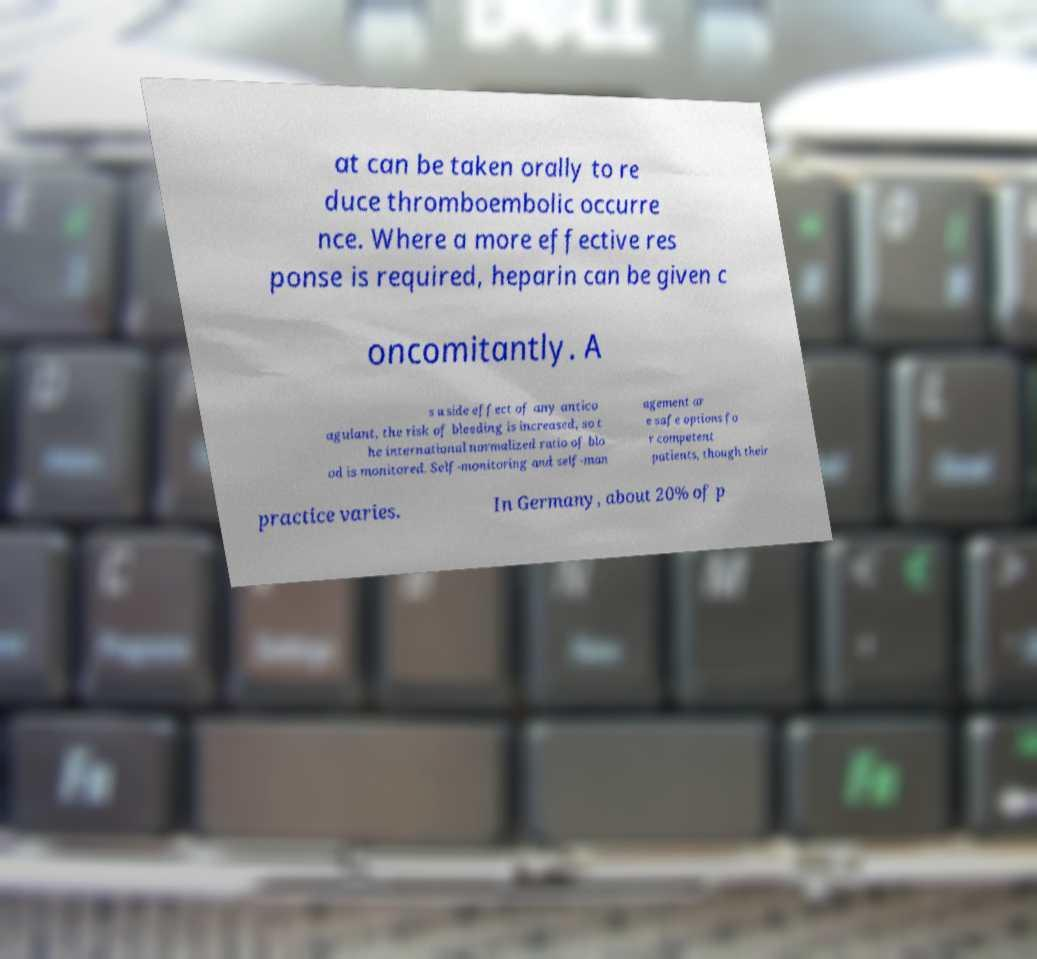Could you assist in decoding the text presented in this image and type it out clearly? at can be taken orally to re duce thromboembolic occurre nce. Where a more effective res ponse is required, heparin can be given c oncomitantly. A s a side effect of any antico agulant, the risk of bleeding is increased, so t he international normalized ratio of blo od is monitored. Self-monitoring and self-man agement ar e safe options fo r competent patients, though their practice varies. In Germany, about 20% of p 